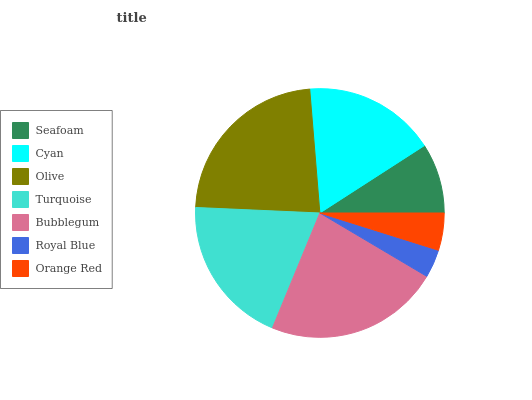Is Royal Blue the minimum?
Answer yes or no. Yes. Is Olive the maximum?
Answer yes or no. Yes. Is Cyan the minimum?
Answer yes or no. No. Is Cyan the maximum?
Answer yes or no. No. Is Cyan greater than Seafoam?
Answer yes or no. Yes. Is Seafoam less than Cyan?
Answer yes or no. Yes. Is Seafoam greater than Cyan?
Answer yes or no. No. Is Cyan less than Seafoam?
Answer yes or no. No. Is Cyan the high median?
Answer yes or no. Yes. Is Cyan the low median?
Answer yes or no. Yes. Is Seafoam the high median?
Answer yes or no. No. Is Olive the low median?
Answer yes or no. No. 